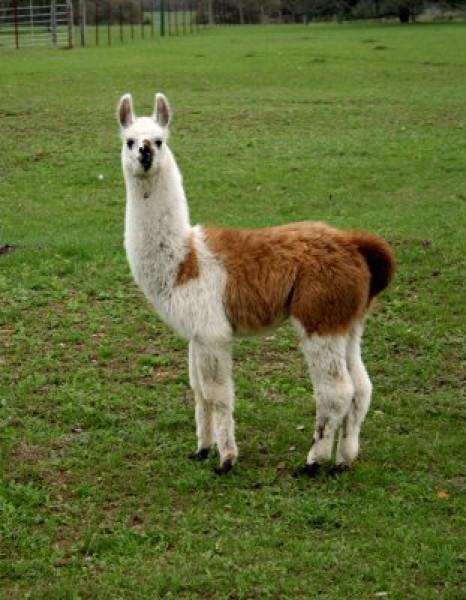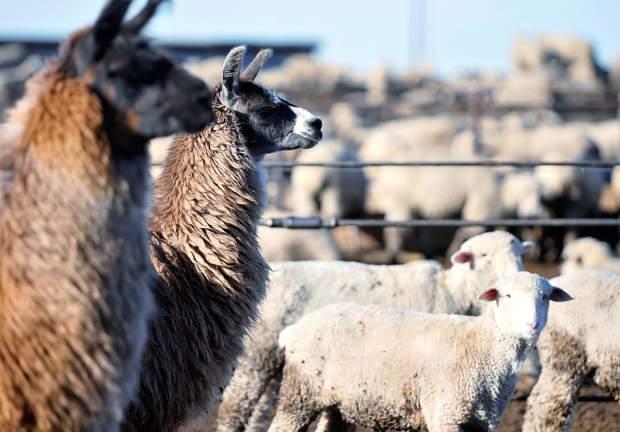The first image is the image on the left, the second image is the image on the right. Analyze the images presented: Is the assertion "There is a single llama in one image." valid? Answer yes or no. Yes. The first image is the image on the left, the second image is the image on the right. Examine the images to the left and right. Is the description "An image contains two llamas standing in front of a fence and near at least one white animal that is not a llama." accurate? Answer yes or no. Yes. 